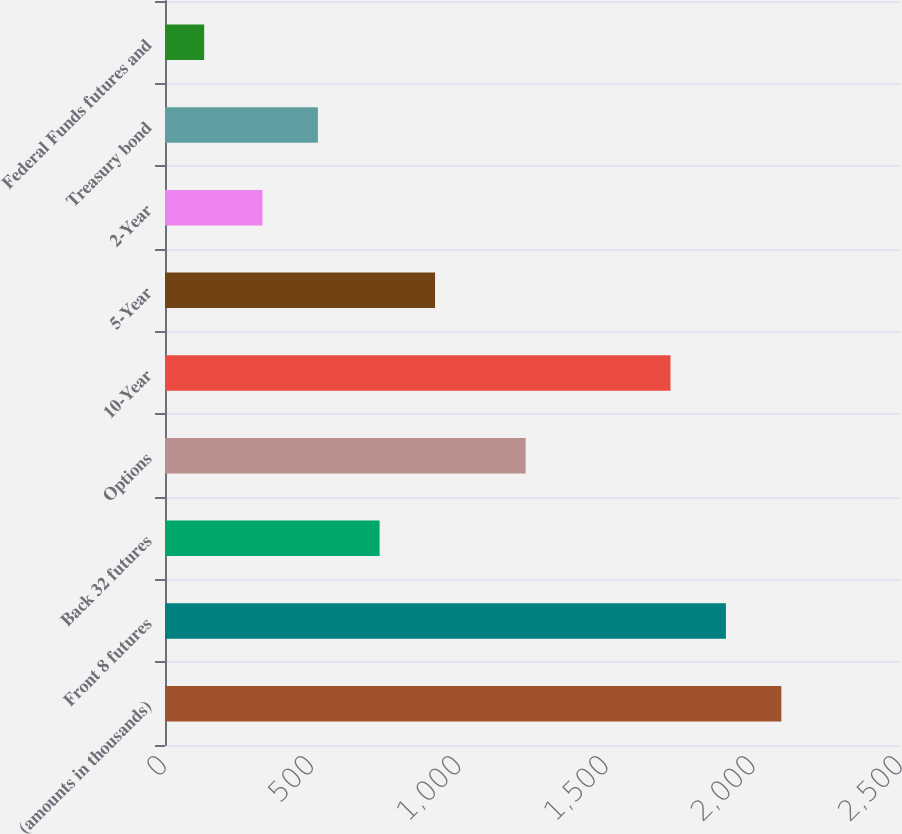Convert chart to OTSL. <chart><loc_0><loc_0><loc_500><loc_500><bar_chart><fcel>(amounts in thousands)<fcel>Front 8 futures<fcel>Back 32 futures<fcel>Options<fcel>10-Year<fcel>5-Year<fcel>2-Year<fcel>Treasury bond<fcel>Federal Funds futures and<nl><fcel>2093.6<fcel>1905.3<fcel>729<fcel>1225<fcel>1717<fcel>917.3<fcel>331<fcel>519.3<fcel>133<nl></chart> 